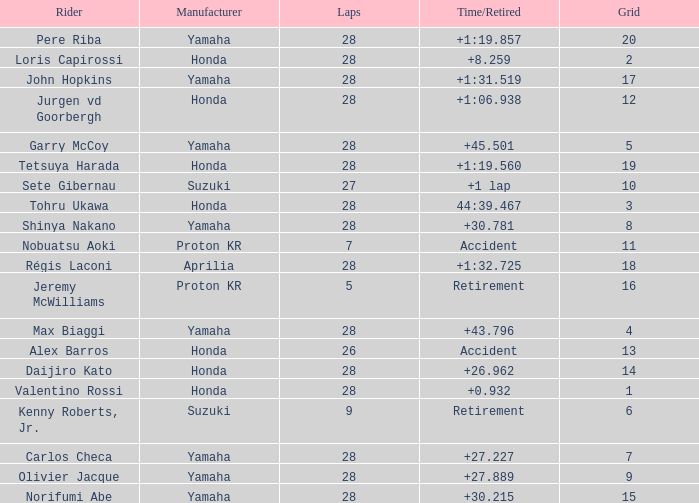How many laps were in grid 4? 28.0. 